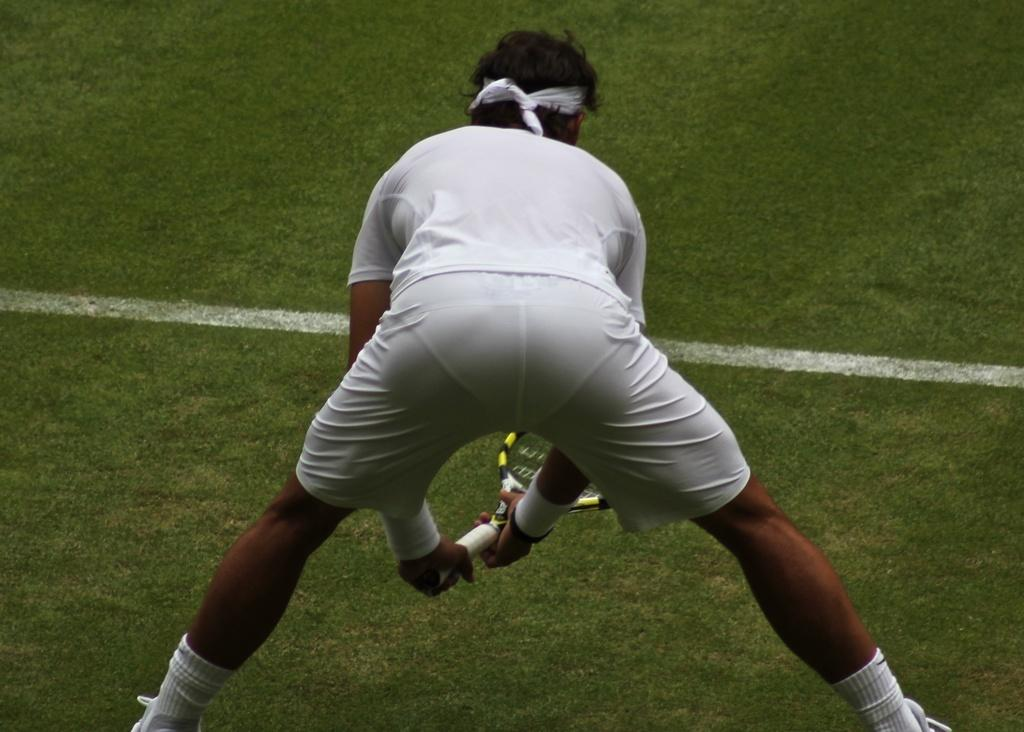What is the person in the image holding? The person is holding a racket in the image. What type of surface is visible in the image? There is green grass visible in the image. How much money is the person holding in the image? There is no money visible in the image; the person is holding a racket. Can you see a toad on the green grass in the image? There is no toad present in the image; only a person holding a racket and green grass are visible. 